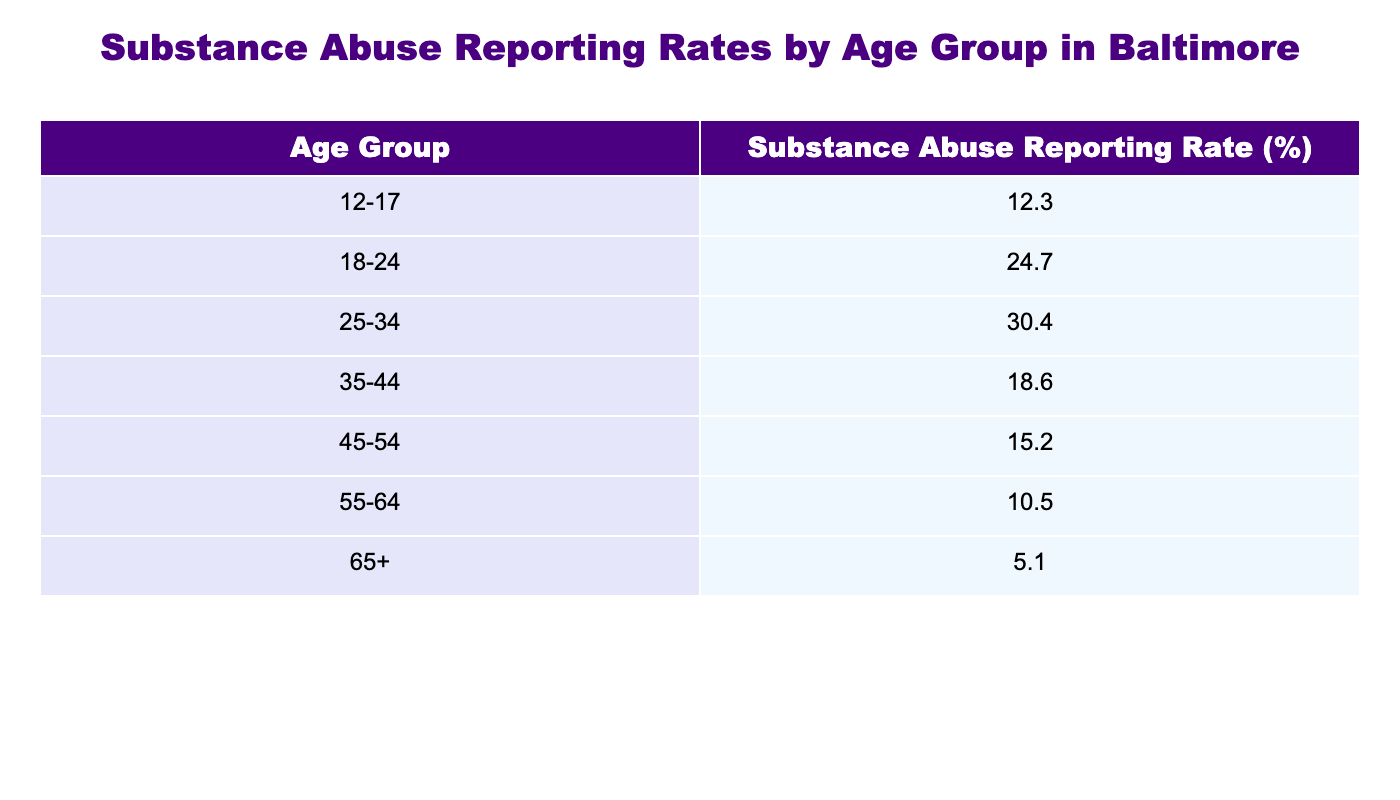What is the substance abuse reporting rate for the age group 18-24? The table shows that the reporting rate for the age group 18-24 is directly listed, which is 24.7%.
Answer: 24.7% Which age group has the highest reporting rate for substance abuse? Comparing the percentages listed in the table, the age group 25-34 has the highest reporting rate at 30.4%.
Answer: 25-34 What is the difference in reporting rates between the age groups 12-17 and 35-44? To find the difference, subtract the reporting rate of 35-44 (18.6%) from that of 12-17 (12.3%). Thus, the difference is 12.3% - 18.6% = -6.3%.
Answer: -6.3% Is the reporting rate for the age group 65+ higher than that for the age group 55-64? The table shows that the reporting rate for the age group 65+ is 5.1%, while for 55-64 it is 10.5%. Since 5.1% is less than 10.5%, the statement is false.
Answer: No What is the average reporting rate for individuals aged 45 and older? To calculate the average for age groups 45-54, 55-64, and 65+, add their rates: 15.2% + 10.5% + 5.1% = 30.8%. Then divide by the number of groups, which is 3. Thus, the average is 30.8% / 3 = 10.27%.
Answer: 10.27% How does the substance abuse reporting rate for the age group 25-34 compare to the overall average of all groups? First, find the overall average by summing all reporting rates: 12.3% + 24.7% + 30.4% + 18.6% + 15.2% + 10.5% + 5.1% = 117.8% from 7 groups, so the average is 117.8% / 7 = 16.83%. Comparing this with the 25-34 rate (30.4%), it is higher than the average.
Answer: Higher than average Which age group shows the lowest reporting rate for substance abuse? The table lists the reporting rates, and it shows that the age group 65+ has the lowest reporting rate at 5.1%.
Answer: 65+ 